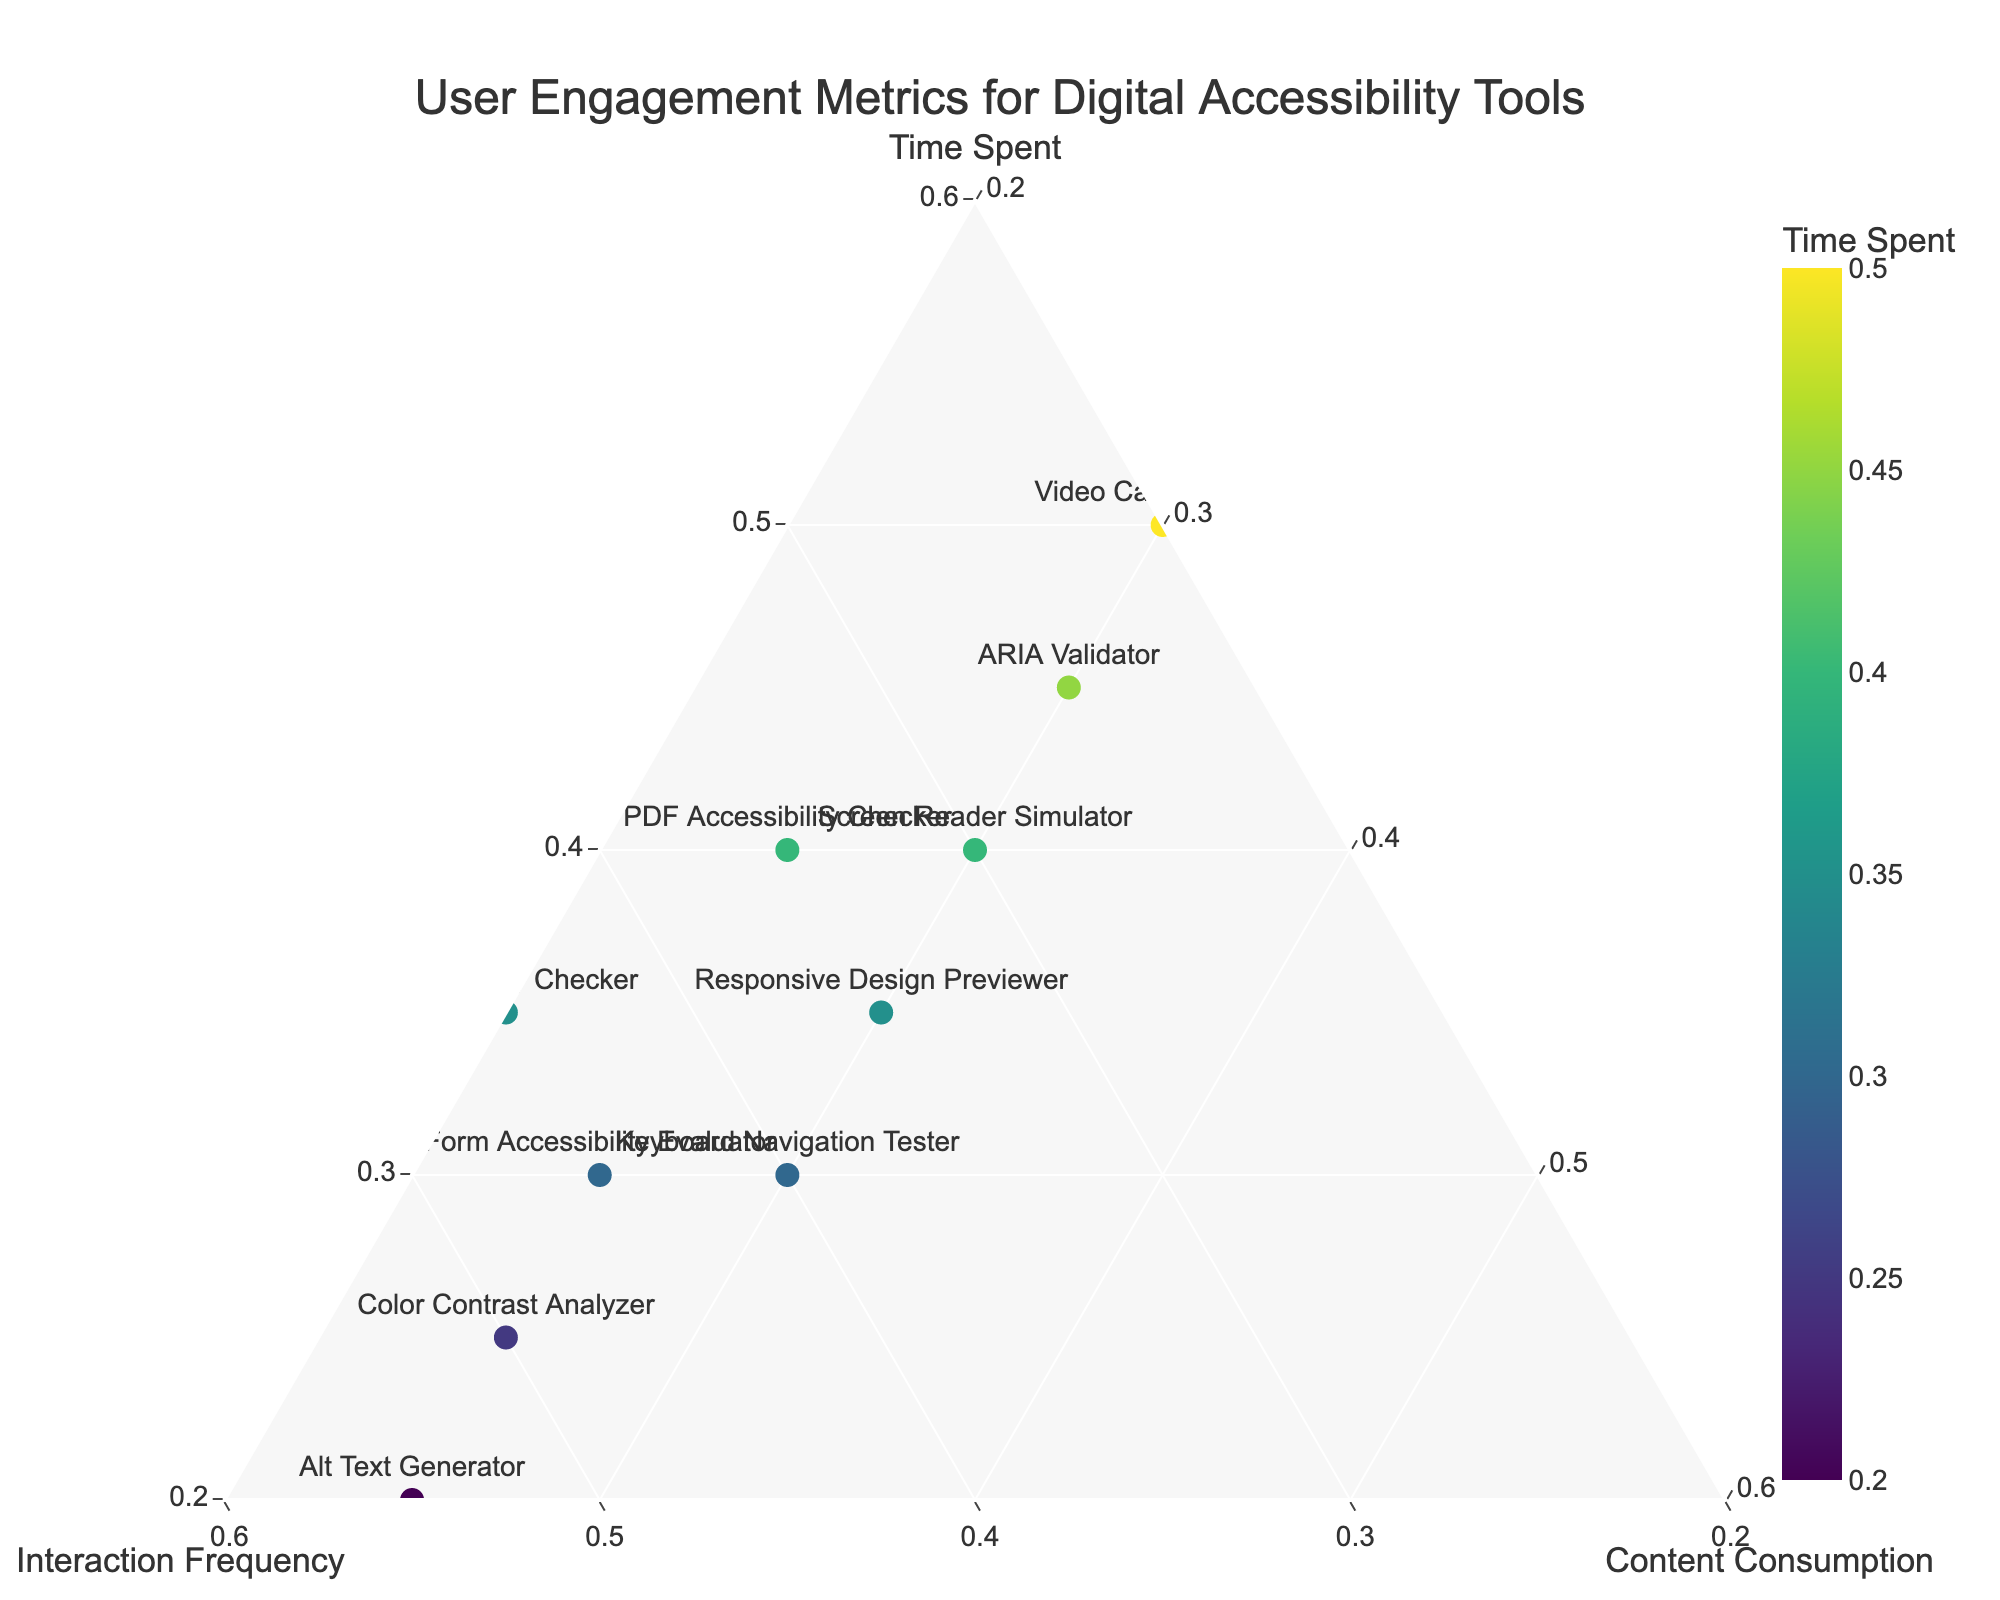What's the title of the figure? The title is usually at the top of the plot. In this case, it reads: "User Engagement Metrics for Digital Accessibility Tools."
Answer: User Engagement Metrics for Digital Accessibility Tools How many data points are there in the plot? Each product is a data point. By counting the products in the plot, we find there are 10 data points.
Answer: 10 Which product shows the highest content consumption rate? Look for the product with the highest 'Content Consumption' component in the ternary plot, which appears near the bottom of the plot's triangle. 'Screen Reader Simulator' and 'Keyboard Navigation Tester' both have high content consumption rates of 0.30.
Answer: Screen Reader Simulator and Keyboard Navigation Tester Which product has the lowest interaction frequency? Locate the data points on the plot with the lowest 'Interaction Frequency' value, which is near the bottom-right of the triangle. 'Video Caption Editor' has an interaction frequency of 0.20, the lowest among all products.
Answer: Video Caption Editor What is the average time spent across all products? Sum all the 'Time Spent' values and then divide by the number of products: (0.35 + 0.40 + 0.25 + 0.30 + 0.45 + 0.20 + 0.35 + 0.30 + 0.40 + 0.50) / 10 = 0.35
Answer: 0.35 Which products have equal time spent and content consumption? Compare the 'Time Spent' and 'Content Consumption' values. 'Screen Reader Simulator' has both values at 0.30, 'Keyboard Navigation Tester' has both at 0.30, and 'Color Contrast Analyzer' has both at 0.25.
Answer: Screen Reader Simulator, Keyboard Navigation Tester, and Color Contrast Analyzer Which product has the highest overall engagement based on the normalized scores seen in the plot? Assess the combination of all three metrics: time spent, interaction frequency, and content consumption. 'Video Caption Editor,' which stands out with 0.50 in time spent and a balanced score for other metrics, appears to have the highest overall engagement.
Answer: Video Caption Editor Are there any products with equal proportions of two different metrics? Identify if any products have two normalized metrics that match. 'Screen Reader Simulator', 'Keyboard Navigation Tester', and 'Color Contrast Analyzer' all have equal content consumption and interaction frequency values.
Answer: Screen Reader Simulator, Keyboard Navigation Tester, and Color Contrast Analyzer What can be said about the relationship between time spent and interaction frequency across the products? Analyze the placement of products that have high values in 'Time Spent' and see their corresponding 'Interaction Frequency' values. Generally, as 'Time Spent' increases, 'Interaction Frequency' tends to vary widely, indicating no strong linear relationship.
Answer: No strong linear relationship 